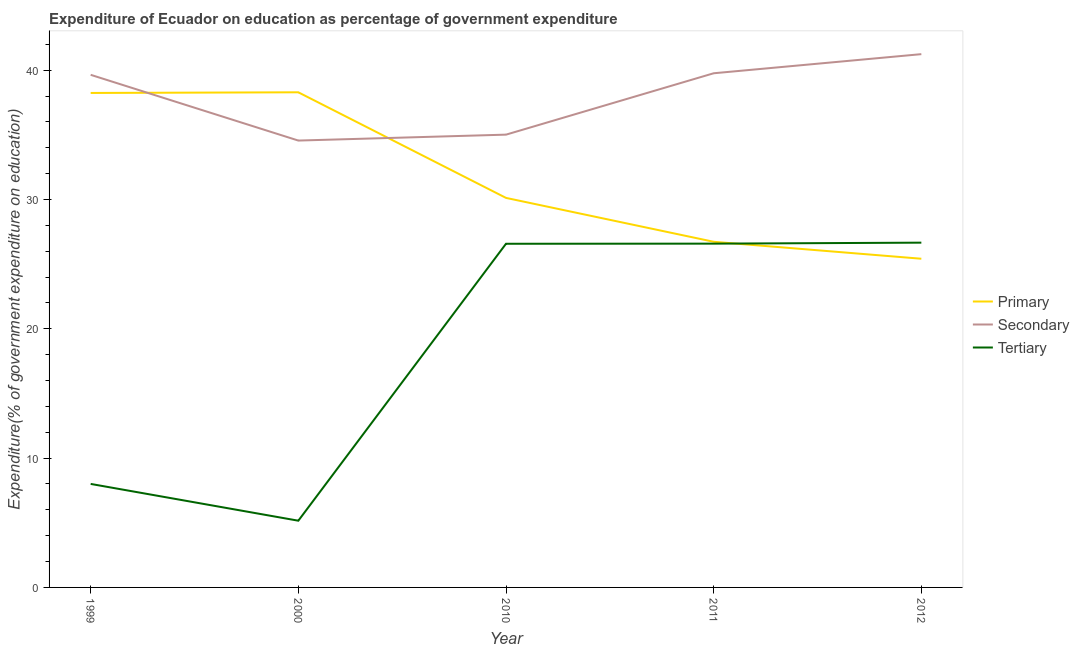Is the number of lines equal to the number of legend labels?
Your answer should be very brief. Yes. What is the expenditure on secondary education in 2010?
Your answer should be compact. 35.01. Across all years, what is the maximum expenditure on tertiary education?
Offer a very short reply. 26.66. Across all years, what is the minimum expenditure on secondary education?
Keep it short and to the point. 34.56. In which year was the expenditure on primary education maximum?
Offer a very short reply. 2000. What is the total expenditure on secondary education in the graph?
Ensure brevity in your answer.  190.21. What is the difference between the expenditure on tertiary education in 1999 and that in 2000?
Keep it short and to the point. 2.84. What is the difference between the expenditure on secondary education in 2012 and the expenditure on primary education in 2011?
Your response must be concise. 14.51. What is the average expenditure on primary education per year?
Ensure brevity in your answer.  31.76. In the year 2011, what is the difference between the expenditure on primary education and expenditure on secondary education?
Your response must be concise. -13.03. In how many years, is the expenditure on primary education greater than 26 %?
Your answer should be very brief. 4. What is the ratio of the expenditure on primary education in 2000 to that in 2011?
Give a very brief answer. 1.43. Is the expenditure on primary education in 2011 less than that in 2012?
Provide a short and direct response. No. Is the difference between the expenditure on primary education in 2000 and 2012 greater than the difference between the expenditure on tertiary education in 2000 and 2012?
Provide a succinct answer. Yes. What is the difference between the highest and the second highest expenditure on secondary education?
Offer a terse response. 1.48. What is the difference between the highest and the lowest expenditure on secondary education?
Your response must be concise. 6.68. In how many years, is the expenditure on primary education greater than the average expenditure on primary education taken over all years?
Your answer should be very brief. 2. Is the sum of the expenditure on primary education in 1999 and 2000 greater than the maximum expenditure on secondary education across all years?
Provide a succinct answer. Yes. How many lines are there?
Offer a very short reply. 3. How many years are there in the graph?
Ensure brevity in your answer.  5. Are the values on the major ticks of Y-axis written in scientific E-notation?
Offer a very short reply. No. Does the graph contain grids?
Give a very brief answer. No. Where does the legend appear in the graph?
Give a very brief answer. Center right. How are the legend labels stacked?
Offer a terse response. Vertical. What is the title of the graph?
Keep it short and to the point. Expenditure of Ecuador on education as percentage of government expenditure. What is the label or title of the Y-axis?
Provide a succinct answer. Expenditure(% of government expenditure on education). What is the Expenditure(% of government expenditure on education) in Primary in 1999?
Offer a very short reply. 38.24. What is the Expenditure(% of government expenditure on education) of Secondary in 1999?
Offer a terse response. 39.64. What is the Expenditure(% of government expenditure on education) of Tertiary in 1999?
Offer a very short reply. 8. What is the Expenditure(% of government expenditure on education) of Primary in 2000?
Your answer should be very brief. 38.29. What is the Expenditure(% of government expenditure on education) in Secondary in 2000?
Give a very brief answer. 34.56. What is the Expenditure(% of government expenditure on education) of Tertiary in 2000?
Your answer should be very brief. 5.16. What is the Expenditure(% of government expenditure on education) in Primary in 2010?
Make the answer very short. 30.12. What is the Expenditure(% of government expenditure on education) in Secondary in 2010?
Provide a succinct answer. 35.01. What is the Expenditure(% of government expenditure on education) of Tertiary in 2010?
Provide a succinct answer. 26.58. What is the Expenditure(% of government expenditure on education) in Primary in 2011?
Provide a short and direct response. 26.73. What is the Expenditure(% of government expenditure on education) of Secondary in 2011?
Your answer should be compact. 39.76. What is the Expenditure(% of government expenditure on education) of Tertiary in 2011?
Your answer should be compact. 26.58. What is the Expenditure(% of government expenditure on education) in Primary in 2012?
Give a very brief answer. 25.42. What is the Expenditure(% of government expenditure on education) of Secondary in 2012?
Your answer should be compact. 41.24. What is the Expenditure(% of government expenditure on education) of Tertiary in 2012?
Provide a short and direct response. 26.66. Across all years, what is the maximum Expenditure(% of government expenditure on education) in Primary?
Offer a terse response. 38.29. Across all years, what is the maximum Expenditure(% of government expenditure on education) in Secondary?
Ensure brevity in your answer.  41.24. Across all years, what is the maximum Expenditure(% of government expenditure on education) of Tertiary?
Ensure brevity in your answer.  26.66. Across all years, what is the minimum Expenditure(% of government expenditure on education) in Primary?
Provide a short and direct response. 25.42. Across all years, what is the minimum Expenditure(% of government expenditure on education) of Secondary?
Ensure brevity in your answer.  34.56. Across all years, what is the minimum Expenditure(% of government expenditure on education) of Tertiary?
Your answer should be very brief. 5.16. What is the total Expenditure(% of government expenditure on education) in Primary in the graph?
Provide a short and direct response. 158.8. What is the total Expenditure(% of government expenditure on education) of Secondary in the graph?
Keep it short and to the point. 190.21. What is the total Expenditure(% of government expenditure on education) of Tertiary in the graph?
Make the answer very short. 92.99. What is the difference between the Expenditure(% of government expenditure on education) in Primary in 1999 and that in 2000?
Provide a succinct answer. -0.05. What is the difference between the Expenditure(% of government expenditure on education) of Secondary in 1999 and that in 2000?
Make the answer very short. 5.08. What is the difference between the Expenditure(% of government expenditure on education) in Tertiary in 1999 and that in 2000?
Give a very brief answer. 2.84. What is the difference between the Expenditure(% of government expenditure on education) of Primary in 1999 and that in 2010?
Your response must be concise. 8.12. What is the difference between the Expenditure(% of government expenditure on education) in Secondary in 1999 and that in 2010?
Provide a short and direct response. 4.63. What is the difference between the Expenditure(% of government expenditure on education) in Tertiary in 1999 and that in 2010?
Keep it short and to the point. -18.57. What is the difference between the Expenditure(% of government expenditure on education) of Primary in 1999 and that in 2011?
Offer a terse response. 11.51. What is the difference between the Expenditure(% of government expenditure on education) of Secondary in 1999 and that in 2011?
Provide a short and direct response. -0.12. What is the difference between the Expenditure(% of government expenditure on education) of Tertiary in 1999 and that in 2011?
Provide a succinct answer. -18.58. What is the difference between the Expenditure(% of government expenditure on education) in Primary in 1999 and that in 2012?
Your answer should be compact. 12.82. What is the difference between the Expenditure(% of government expenditure on education) of Secondary in 1999 and that in 2012?
Make the answer very short. -1.6. What is the difference between the Expenditure(% of government expenditure on education) of Tertiary in 1999 and that in 2012?
Provide a succinct answer. -18.66. What is the difference between the Expenditure(% of government expenditure on education) in Primary in 2000 and that in 2010?
Your response must be concise. 8.17. What is the difference between the Expenditure(% of government expenditure on education) of Secondary in 2000 and that in 2010?
Offer a very short reply. -0.46. What is the difference between the Expenditure(% of government expenditure on education) of Tertiary in 2000 and that in 2010?
Offer a very short reply. -21.42. What is the difference between the Expenditure(% of government expenditure on education) of Primary in 2000 and that in 2011?
Your response must be concise. 11.56. What is the difference between the Expenditure(% of government expenditure on education) in Secondary in 2000 and that in 2011?
Provide a succinct answer. -5.2. What is the difference between the Expenditure(% of government expenditure on education) in Tertiary in 2000 and that in 2011?
Your answer should be very brief. -21.42. What is the difference between the Expenditure(% of government expenditure on education) of Primary in 2000 and that in 2012?
Provide a succinct answer. 12.87. What is the difference between the Expenditure(% of government expenditure on education) in Secondary in 2000 and that in 2012?
Offer a very short reply. -6.68. What is the difference between the Expenditure(% of government expenditure on education) in Tertiary in 2000 and that in 2012?
Give a very brief answer. -21.5. What is the difference between the Expenditure(% of government expenditure on education) in Primary in 2010 and that in 2011?
Your answer should be compact. 3.39. What is the difference between the Expenditure(% of government expenditure on education) of Secondary in 2010 and that in 2011?
Offer a terse response. -4.75. What is the difference between the Expenditure(% of government expenditure on education) of Tertiary in 2010 and that in 2011?
Provide a short and direct response. -0.01. What is the difference between the Expenditure(% of government expenditure on education) of Primary in 2010 and that in 2012?
Your response must be concise. 4.71. What is the difference between the Expenditure(% of government expenditure on education) in Secondary in 2010 and that in 2012?
Keep it short and to the point. -6.22. What is the difference between the Expenditure(% of government expenditure on education) in Tertiary in 2010 and that in 2012?
Provide a short and direct response. -0.08. What is the difference between the Expenditure(% of government expenditure on education) of Primary in 2011 and that in 2012?
Provide a short and direct response. 1.31. What is the difference between the Expenditure(% of government expenditure on education) of Secondary in 2011 and that in 2012?
Your answer should be compact. -1.48. What is the difference between the Expenditure(% of government expenditure on education) in Tertiary in 2011 and that in 2012?
Your answer should be compact. -0.08. What is the difference between the Expenditure(% of government expenditure on education) of Primary in 1999 and the Expenditure(% of government expenditure on education) of Secondary in 2000?
Keep it short and to the point. 3.68. What is the difference between the Expenditure(% of government expenditure on education) of Primary in 1999 and the Expenditure(% of government expenditure on education) of Tertiary in 2000?
Your response must be concise. 33.08. What is the difference between the Expenditure(% of government expenditure on education) of Secondary in 1999 and the Expenditure(% of government expenditure on education) of Tertiary in 2000?
Ensure brevity in your answer.  34.48. What is the difference between the Expenditure(% of government expenditure on education) of Primary in 1999 and the Expenditure(% of government expenditure on education) of Secondary in 2010?
Keep it short and to the point. 3.22. What is the difference between the Expenditure(% of government expenditure on education) in Primary in 1999 and the Expenditure(% of government expenditure on education) in Tertiary in 2010?
Your response must be concise. 11.66. What is the difference between the Expenditure(% of government expenditure on education) of Secondary in 1999 and the Expenditure(% of government expenditure on education) of Tertiary in 2010?
Your answer should be compact. 13.06. What is the difference between the Expenditure(% of government expenditure on education) in Primary in 1999 and the Expenditure(% of government expenditure on education) in Secondary in 2011?
Provide a short and direct response. -1.52. What is the difference between the Expenditure(% of government expenditure on education) of Primary in 1999 and the Expenditure(% of government expenditure on education) of Tertiary in 2011?
Keep it short and to the point. 11.65. What is the difference between the Expenditure(% of government expenditure on education) in Secondary in 1999 and the Expenditure(% of government expenditure on education) in Tertiary in 2011?
Provide a short and direct response. 13.06. What is the difference between the Expenditure(% of government expenditure on education) in Primary in 1999 and the Expenditure(% of government expenditure on education) in Secondary in 2012?
Your answer should be very brief. -3. What is the difference between the Expenditure(% of government expenditure on education) of Primary in 1999 and the Expenditure(% of government expenditure on education) of Tertiary in 2012?
Give a very brief answer. 11.58. What is the difference between the Expenditure(% of government expenditure on education) in Secondary in 1999 and the Expenditure(% of government expenditure on education) in Tertiary in 2012?
Provide a short and direct response. 12.98. What is the difference between the Expenditure(% of government expenditure on education) of Primary in 2000 and the Expenditure(% of government expenditure on education) of Secondary in 2010?
Provide a short and direct response. 3.27. What is the difference between the Expenditure(% of government expenditure on education) of Primary in 2000 and the Expenditure(% of government expenditure on education) of Tertiary in 2010?
Your answer should be compact. 11.71. What is the difference between the Expenditure(% of government expenditure on education) of Secondary in 2000 and the Expenditure(% of government expenditure on education) of Tertiary in 2010?
Offer a very short reply. 7.98. What is the difference between the Expenditure(% of government expenditure on education) in Primary in 2000 and the Expenditure(% of government expenditure on education) in Secondary in 2011?
Offer a terse response. -1.47. What is the difference between the Expenditure(% of government expenditure on education) of Primary in 2000 and the Expenditure(% of government expenditure on education) of Tertiary in 2011?
Your answer should be compact. 11.7. What is the difference between the Expenditure(% of government expenditure on education) of Secondary in 2000 and the Expenditure(% of government expenditure on education) of Tertiary in 2011?
Offer a terse response. 7.97. What is the difference between the Expenditure(% of government expenditure on education) of Primary in 2000 and the Expenditure(% of government expenditure on education) of Secondary in 2012?
Make the answer very short. -2.95. What is the difference between the Expenditure(% of government expenditure on education) in Primary in 2000 and the Expenditure(% of government expenditure on education) in Tertiary in 2012?
Provide a succinct answer. 11.63. What is the difference between the Expenditure(% of government expenditure on education) in Secondary in 2000 and the Expenditure(% of government expenditure on education) in Tertiary in 2012?
Your answer should be compact. 7.9. What is the difference between the Expenditure(% of government expenditure on education) of Primary in 2010 and the Expenditure(% of government expenditure on education) of Secondary in 2011?
Keep it short and to the point. -9.64. What is the difference between the Expenditure(% of government expenditure on education) of Primary in 2010 and the Expenditure(% of government expenditure on education) of Tertiary in 2011?
Your answer should be very brief. 3.54. What is the difference between the Expenditure(% of government expenditure on education) of Secondary in 2010 and the Expenditure(% of government expenditure on education) of Tertiary in 2011?
Provide a succinct answer. 8.43. What is the difference between the Expenditure(% of government expenditure on education) of Primary in 2010 and the Expenditure(% of government expenditure on education) of Secondary in 2012?
Your answer should be compact. -11.12. What is the difference between the Expenditure(% of government expenditure on education) of Primary in 2010 and the Expenditure(% of government expenditure on education) of Tertiary in 2012?
Your answer should be very brief. 3.46. What is the difference between the Expenditure(% of government expenditure on education) of Secondary in 2010 and the Expenditure(% of government expenditure on education) of Tertiary in 2012?
Offer a terse response. 8.35. What is the difference between the Expenditure(% of government expenditure on education) in Primary in 2011 and the Expenditure(% of government expenditure on education) in Secondary in 2012?
Provide a succinct answer. -14.51. What is the difference between the Expenditure(% of government expenditure on education) in Primary in 2011 and the Expenditure(% of government expenditure on education) in Tertiary in 2012?
Your answer should be compact. 0.07. What is the difference between the Expenditure(% of government expenditure on education) of Secondary in 2011 and the Expenditure(% of government expenditure on education) of Tertiary in 2012?
Your response must be concise. 13.1. What is the average Expenditure(% of government expenditure on education) in Primary per year?
Ensure brevity in your answer.  31.76. What is the average Expenditure(% of government expenditure on education) in Secondary per year?
Provide a succinct answer. 38.04. What is the average Expenditure(% of government expenditure on education) of Tertiary per year?
Your response must be concise. 18.6. In the year 1999, what is the difference between the Expenditure(% of government expenditure on education) in Primary and Expenditure(% of government expenditure on education) in Secondary?
Make the answer very short. -1.4. In the year 1999, what is the difference between the Expenditure(% of government expenditure on education) in Primary and Expenditure(% of government expenditure on education) in Tertiary?
Provide a short and direct response. 30.23. In the year 1999, what is the difference between the Expenditure(% of government expenditure on education) of Secondary and Expenditure(% of government expenditure on education) of Tertiary?
Your response must be concise. 31.64. In the year 2000, what is the difference between the Expenditure(% of government expenditure on education) in Primary and Expenditure(% of government expenditure on education) in Secondary?
Make the answer very short. 3.73. In the year 2000, what is the difference between the Expenditure(% of government expenditure on education) in Primary and Expenditure(% of government expenditure on education) in Tertiary?
Ensure brevity in your answer.  33.13. In the year 2000, what is the difference between the Expenditure(% of government expenditure on education) of Secondary and Expenditure(% of government expenditure on education) of Tertiary?
Make the answer very short. 29.4. In the year 2010, what is the difference between the Expenditure(% of government expenditure on education) in Primary and Expenditure(% of government expenditure on education) in Secondary?
Offer a very short reply. -4.89. In the year 2010, what is the difference between the Expenditure(% of government expenditure on education) in Primary and Expenditure(% of government expenditure on education) in Tertiary?
Your response must be concise. 3.55. In the year 2010, what is the difference between the Expenditure(% of government expenditure on education) in Secondary and Expenditure(% of government expenditure on education) in Tertiary?
Your answer should be compact. 8.44. In the year 2011, what is the difference between the Expenditure(% of government expenditure on education) in Primary and Expenditure(% of government expenditure on education) in Secondary?
Your response must be concise. -13.03. In the year 2011, what is the difference between the Expenditure(% of government expenditure on education) of Primary and Expenditure(% of government expenditure on education) of Tertiary?
Offer a very short reply. 0.14. In the year 2011, what is the difference between the Expenditure(% of government expenditure on education) of Secondary and Expenditure(% of government expenditure on education) of Tertiary?
Keep it short and to the point. 13.18. In the year 2012, what is the difference between the Expenditure(% of government expenditure on education) of Primary and Expenditure(% of government expenditure on education) of Secondary?
Make the answer very short. -15.82. In the year 2012, what is the difference between the Expenditure(% of government expenditure on education) of Primary and Expenditure(% of government expenditure on education) of Tertiary?
Give a very brief answer. -1.24. In the year 2012, what is the difference between the Expenditure(% of government expenditure on education) of Secondary and Expenditure(% of government expenditure on education) of Tertiary?
Keep it short and to the point. 14.58. What is the ratio of the Expenditure(% of government expenditure on education) in Primary in 1999 to that in 2000?
Your answer should be compact. 1. What is the ratio of the Expenditure(% of government expenditure on education) in Secondary in 1999 to that in 2000?
Make the answer very short. 1.15. What is the ratio of the Expenditure(% of government expenditure on education) of Tertiary in 1999 to that in 2000?
Your answer should be compact. 1.55. What is the ratio of the Expenditure(% of government expenditure on education) of Primary in 1999 to that in 2010?
Make the answer very short. 1.27. What is the ratio of the Expenditure(% of government expenditure on education) in Secondary in 1999 to that in 2010?
Your answer should be compact. 1.13. What is the ratio of the Expenditure(% of government expenditure on education) in Tertiary in 1999 to that in 2010?
Your response must be concise. 0.3. What is the ratio of the Expenditure(% of government expenditure on education) of Primary in 1999 to that in 2011?
Provide a short and direct response. 1.43. What is the ratio of the Expenditure(% of government expenditure on education) in Tertiary in 1999 to that in 2011?
Offer a terse response. 0.3. What is the ratio of the Expenditure(% of government expenditure on education) of Primary in 1999 to that in 2012?
Keep it short and to the point. 1.5. What is the ratio of the Expenditure(% of government expenditure on education) in Secondary in 1999 to that in 2012?
Give a very brief answer. 0.96. What is the ratio of the Expenditure(% of government expenditure on education) in Tertiary in 1999 to that in 2012?
Ensure brevity in your answer.  0.3. What is the ratio of the Expenditure(% of government expenditure on education) in Primary in 2000 to that in 2010?
Offer a very short reply. 1.27. What is the ratio of the Expenditure(% of government expenditure on education) of Secondary in 2000 to that in 2010?
Ensure brevity in your answer.  0.99. What is the ratio of the Expenditure(% of government expenditure on education) in Tertiary in 2000 to that in 2010?
Your answer should be very brief. 0.19. What is the ratio of the Expenditure(% of government expenditure on education) in Primary in 2000 to that in 2011?
Offer a very short reply. 1.43. What is the ratio of the Expenditure(% of government expenditure on education) of Secondary in 2000 to that in 2011?
Give a very brief answer. 0.87. What is the ratio of the Expenditure(% of government expenditure on education) in Tertiary in 2000 to that in 2011?
Offer a terse response. 0.19. What is the ratio of the Expenditure(% of government expenditure on education) in Primary in 2000 to that in 2012?
Your response must be concise. 1.51. What is the ratio of the Expenditure(% of government expenditure on education) in Secondary in 2000 to that in 2012?
Your answer should be compact. 0.84. What is the ratio of the Expenditure(% of government expenditure on education) of Tertiary in 2000 to that in 2012?
Provide a short and direct response. 0.19. What is the ratio of the Expenditure(% of government expenditure on education) in Primary in 2010 to that in 2011?
Ensure brevity in your answer.  1.13. What is the ratio of the Expenditure(% of government expenditure on education) of Secondary in 2010 to that in 2011?
Provide a short and direct response. 0.88. What is the ratio of the Expenditure(% of government expenditure on education) of Tertiary in 2010 to that in 2011?
Make the answer very short. 1. What is the ratio of the Expenditure(% of government expenditure on education) in Primary in 2010 to that in 2012?
Your response must be concise. 1.19. What is the ratio of the Expenditure(% of government expenditure on education) in Secondary in 2010 to that in 2012?
Ensure brevity in your answer.  0.85. What is the ratio of the Expenditure(% of government expenditure on education) in Tertiary in 2010 to that in 2012?
Your answer should be very brief. 1. What is the ratio of the Expenditure(% of government expenditure on education) in Primary in 2011 to that in 2012?
Provide a succinct answer. 1.05. What is the ratio of the Expenditure(% of government expenditure on education) in Secondary in 2011 to that in 2012?
Your answer should be compact. 0.96. What is the ratio of the Expenditure(% of government expenditure on education) in Tertiary in 2011 to that in 2012?
Make the answer very short. 1. What is the difference between the highest and the second highest Expenditure(% of government expenditure on education) in Primary?
Ensure brevity in your answer.  0.05. What is the difference between the highest and the second highest Expenditure(% of government expenditure on education) in Secondary?
Your answer should be compact. 1.48. What is the difference between the highest and the second highest Expenditure(% of government expenditure on education) of Tertiary?
Offer a very short reply. 0.08. What is the difference between the highest and the lowest Expenditure(% of government expenditure on education) of Primary?
Your answer should be very brief. 12.87. What is the difference between the highest and the lowest Expenditure(% of government expenditure on education) of Secondary?
Offer a terse response. 6.68. What is the difference between the highest and the lowest Expenditure(% of government expenditure on education) in Tertiary?
Your answer should be very brief. 21.5. 